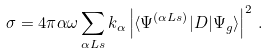Convert formula to latex. <formula><loc_0><loc_0><loc_500><loc_500>\sigma = { 4 \pi } { \alpha \omega } \sum _ { \alpha L s } { k } _ { \alpha } \left | \langle \Psi ^ { ( \alpha L s ) } | D | \Psi _ { g } \rangle \right | ^ { 2 } \, .</formula> 